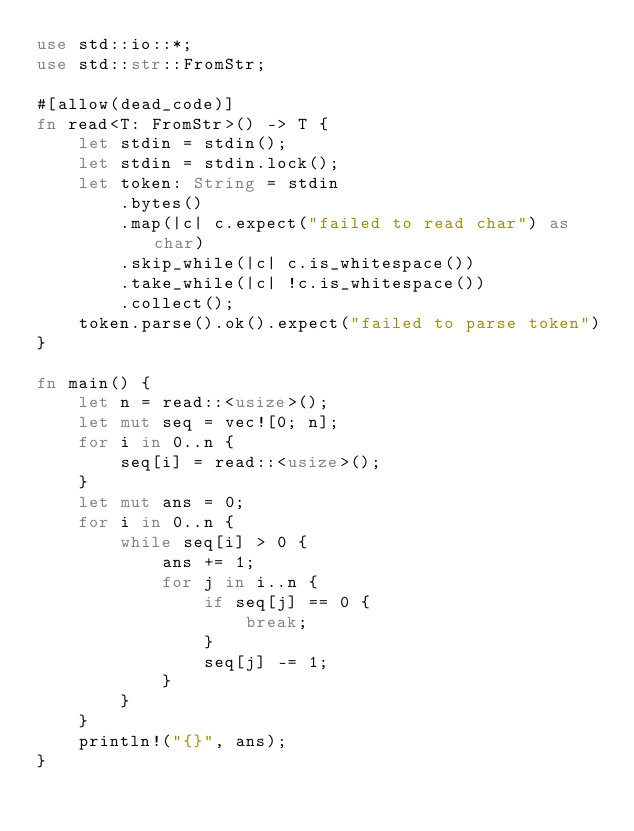<code> <loc_0><loc_0><loc_500><loc_500><_Rust_>use std::io::*;
use std::str::FromStr;

#[allow(dead_code)]
fn read<T: FromStr>() -> T {
    let stdin = stdin();
    let stdin = stdin.lock();
    let token: String = stdin
        .bytes()
        .map(|c| c.expect("failed to read char") as char)
        .skip_while(|c| c.is_whitespace())
        .take_while(|c| !c.is_whitespace())
        .collect();
    token.parse().ok().expect("failed to parse token")
}

fn main() {
    let n = read::<usize>();
    let mut seq = vec![0; n];
    for i in 0..n {
        seq[i] = read::<usize>();
    }
    let mut ans = 0;
    for i in 0..n {
        while seq[i] > 0 {
            ans += 1;
            for j in i..n {
                if seq[j] == 0 {
                    break;
                }
                seq[j] -= 1;
            }
        }
    }
    println!("{}", ans);
}
</code> 